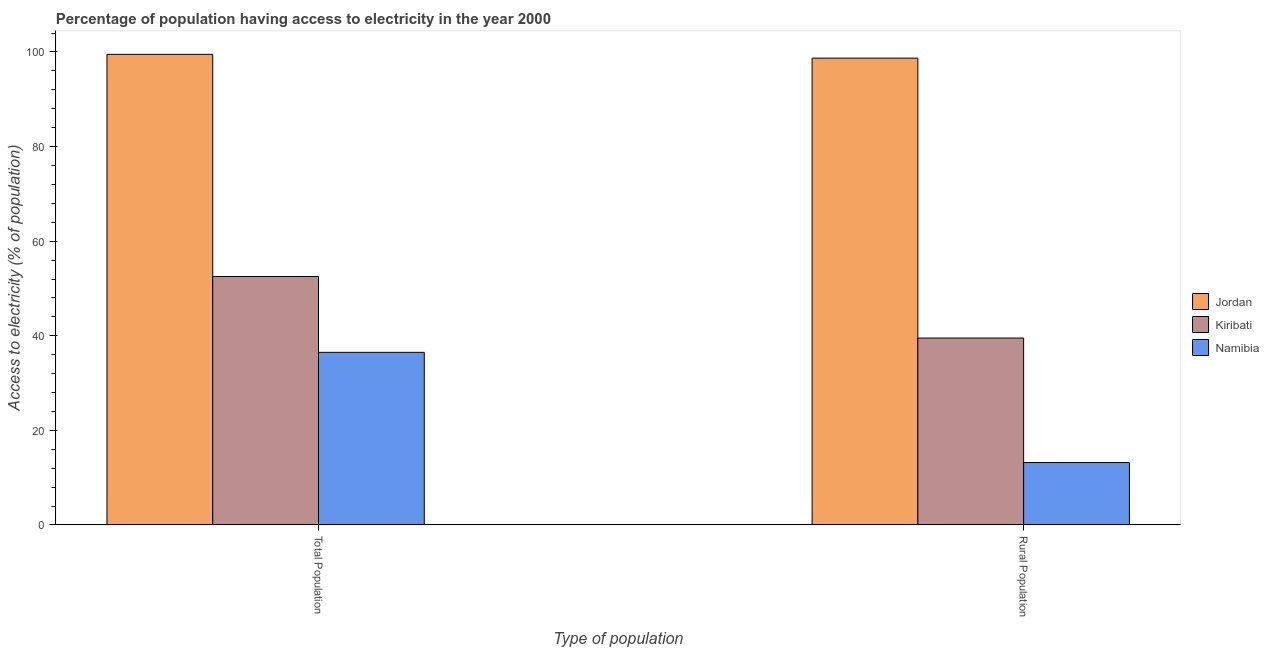How many groups of bars are there?
Make the answer very short. 2. Are the number of bars per tick equal to the number of legend labels?
Give a very brief answer. Yes. How many bars are there on the 1st tick from the left?
Your answer should be very brief. 3. What is the label of the 2nd group of bars from the left?
Provide a succinct answer. Rural Population. What is the percentage of rural population having access to electricity in Jordan?
Your response must be concise. 98.7. Across all countries, what is the maximum percentage of rural population having access to electricity?
Your response must be concise. 98.7. Across all countries, what is the minimum percentage of rural population having access to electricity?
Give a very brief answer. 13.2. In which country was the percentage of population having access to electricity maximum?
Offer a very short reply. Jordan. In which country was the percentage of rural population having access to electricity minimum?
Offer a terse response. Namibia. What is the total percentage of population having access to electricity in the graph?
Ensure brevity in your answer.  188.53. What is the difference between the percentage of rural population having access to electricity in Namibia and that in Jordan?
Provide a succinct answer. -85.5. What is the difference between the percentage of population having access to electricity in Namibia and the percentage of rural population having access to electricity in Kiribati?
Ensure brevity in your answer.  -3.02. What is the average percentage of population having access to electricity per country?
Make the answer very short. 62.84. What is the difference between the percentage of rural population having access to electricity and percentage of population having access to electricity in Namibia?
Offer a terse response. -23.3. What is the ratio of the percentage of rural population having access to electricity in Kiribati to that in Jordan?
Give a very brief answer. 0.4. Is the percentage of rural population having access to electricity in Kiribati less than that in Jordan?
Give a very brief answer. Yes. What does the 3rd bar from the left in Rural Population represents?
Provide a succinct answer. Namibia. What does the 2nd bar from the right in Total Population represents?
Make the answer very short. Kiribati. How many countries are there in the graph?
Provide a succinct answer. 3. What is the difference between two consecutive major ticks on the Y-axis?
Ensure brevity in your answer.  20. Where does the legend appear in the graph?
Keep it short and to the point. Center right. How many legend labels are there?
Ensure brevity in your answer.  3. What is the title of the graph?
Your response must be concise. Percentage of population having access to electricity in the year 2000. What is the label or title of the X-axis?
Your response must be concise. Type of population. What is the label or title of the Y-axis?
Make the answer very short. Access to electricity (% of population). What is the Access to electricity (% of population) in Jordan in Total Population?
Give a very brief answer. 99.5. What is the Access to electricity (% of population) in Kiribati in Total Population?
Ensure brevity in your answer.  52.53. What is the Access to electricity (% of population) of Namibia in Total Population?
Give a very brief answer. 36.5. What is the Access to electricity (% of population) in Jordan in Rural Population?
Ensure brevity in your answer.  98.7. What is the Access to electricity (% of population) of Kiribati in Rural Population?
Your answer should be compact. 39.52. Across all Type of population, what is the maximum Access to electricity (% of population) in Jordan?
Your answer should be very brief. 99.5. Across all Type of population, what is the maximum Access to electricity (% of population) of Kiribati?
Offer a very short reply. 52.53. Across all Type of population, what is the maximum Access to electricity (% of population) of Namibia?
Provide a short and direct response. 36.5. Across all Type of population, what is the minimum Access to electricity (% of population) of Jordan?
Make the answer very short. 98.7. Across all Type of population, what is the minimum Access to electricity (% of population) in Kiribati?
Your response must be concise. 39.52. Across all Type of population, what is the minimum Access to electricity (% of population) in Namibia?
Offer a very short reply. 13.2. What is the total Access to electricity (% of population) in Jordan in the graph?
Provide a short and direct response. 198.2. What is the total Access to electricity (% of population) in Kiribati in the graph?
Make the answer very short. 92.05. What is the total Access to electricity (% of population) of Namibia in the graph?
Keep it short and to the point. 49.7. What is the difference between the Access to electricity (% of population) in Kiribati in Total Population and that in Rural Population?
Keep it short and to the point. 13.01. What is the difference between the Access to electricity (% of population) of Namibia in Total Population and that in Rural Population?
Offer a very short reply. 23.3. What is the difference between the Access to electricity (% of population) of Jordan in Total Population and the Access to electricity (% of population) of Kiribati in Rural Population?
Ensure brevity in your answer.  59.98. What is the difference between the Access to electricity (% of population) of Jordan in Total Population and the Access to electricity (% of population) of Namibia in Rural Population?
Provide a short and direct response. 86.3. What is the difference between the Access to electricity (% of population) in Kiribati in Total Population and the Access to electricity (% of population) in Namibia in Rural Population?
Your answer should be compact. 39.33. What is the average Access to electricity (% of population) in Jordan per Type of population?
Ensure brevity in your answer.  99.1. What is the average Access to electricity (% of population) in Kiribati per Type of population?
Your answer should be compact. 46.03. What is the average Access to electricity (% of population) of Namibia per Type of population?
Keep it short and to the point. 24.85. What is the difference between the Access to electricity (% of population) of Jordan and Access to electricity (% of population) of Kiribati in Total Population?
Your answer should be very brief. 46.97. What is the difference between the Access to electricity (% of population) of Jordan and Access to electricity (% of population) of Namibia in Total Population?
Your response must be concise. 63. What is the difference between the Access to electricity (% of population) in Kiribati and Access to electricity (% of population) in Namibia in Total Population?
Your answer should be very brief. 16.03. What is the difference between the Access to electricity (% of population) in Jordan and Access to electricity (% of population) in Kiribati in Rural Population?
Your answer should be compact. 59.18. What is the difference between the Access to electricity (% of population) of Jordan and Access to electricity (% of population) of Namibia in Rural Population?
Provide a succinct answer. 85.5. What is the difference between the Access to electricity (% of population) of Kiribati and Access to electricity (% of population) of Namibia in Rural Population?
Give a very brief answer. 26.32. What is the ratio of the Access to electricity (% of population) of Jordan in Total Population to that in Rural Population?
Give a very brief answer. 1.01. What is the ratio of the Access to electricity (% of population) of Kiribati in Total Population to that in Rural Population?
Your response must be concise. 1.33. What is the ratio of the Access to electricity (% of population) in Namibia in Total Population to that in Rural Population?
Keep it short and to the point. 2.77. What is the difference between the highest and the second highest Access to electricity (% of population) of Kiribati?
Your response must be concise. 13.01. What is the difference between the highest and the second highest Access to electricity (% of population) of Namibia?
Your response must be concise. 23.3. What is the difference between the highest and the lowest Access to electricity (% of population) of Kiribati?
Your response must be concise. 13.01. What is the difference between the highest and the lowest Access to electricity (% of population) in Namibia?
Provide a short and direct response. 23.3. 